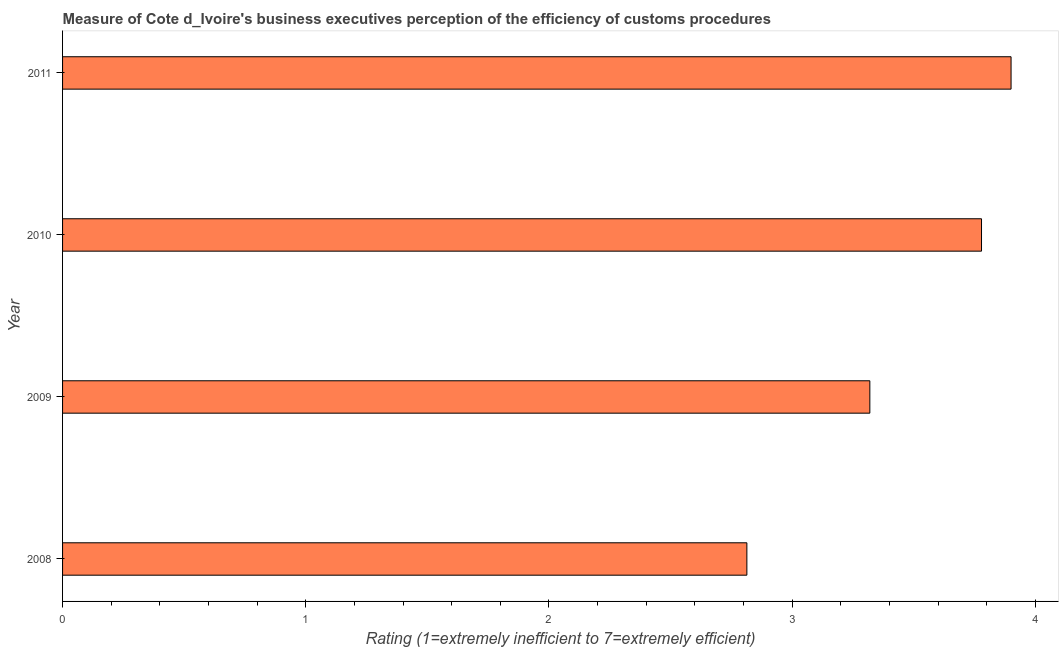What is the title of the graph?
Your answer should be very brief. Measure of Cote d_Ivoire's business executives perception of the efficiency of customs procedures. What is the label or title of the X-axis?
Make the answer very short. Rating (1=extremely inefficient to 7=extremely efficient). What is the rating measuring burden of customs procedure in 2008?
Keep it short and to the point. 2.81. Across all years, what is the minimum rating measuring burden of customs procedure?
Offer a very short reply. 2.81. What is the sum of the rating measuring burden of customs procedure?
Ensure brevity in your answer.  13.81. What is the difference between the rating measuring burden of customs procedure in 2008 and 2009?
Keep it short and to the point. -0.51. What is the average rating measuring burden of customs procedure per year?
Offer a terse response. 3.45. What is the median rating measuring burden of customs procedure?
Offer a terse response. 3.55. What is the ratio of the rating measuring burden of customs procedure in 2009 to that in 2011?
Your answer should be very brief. 0.85. Is the difference between the rating measuring burden of customs procedure in 2009 and 2011 greater than the difference between any two years?
Give a very brief answer. No. What is the difference between the highest and the second highest rating measuring burden of customs procedure?
Ensure brevity in your answer.  0.12. What is the difference between the highest and the lowest rating measuring burden of customs procedure?
Make the answer very short. 1.09. In how many years, is the rating measuring burden of customs procedure greater than the average rating measuring burden of customs procedure taken over all years?
Offer a terse response. 2. How many bars are there?
Your answer should be very brief. 4. Are all the bars in the graph horizontal?
Offer a very short reply. Yes. How many years are there in the graph?
Offer a terse response. 4. What is the difference between two consecutive major ticks on the X-axis?
Keep it short and to the point. 1. What is the Rating (1=extremely inefficient to 7=extremely efficient) of 2008?
Offer a terse response. 2.81. What is the Rating (1=extremely inefficient to 7=extremely efficient) in 2009?
Provide a succinct answer. 3.32. What is the Rating (1=extremely inefficient to 7=extremely efficient) in 2010?
Your answer should be very brief. 3.78. What is the Rating (1=extremely inefficient to 7=extremely efficient) of 2011?
Provide a succinct answer. 3.9. What is the difference between the Rating (1=extremely inefficient to 7=extremely efficient) in 2008 and 2009?
Make the answer very short. -0.51. What is the difference between the Rating (1=extremely inefficient to 7=extremely efficient) in 2008 and 2010?
Provide a short and direct response. -0.96. What is the difference between the Rating (1=extremely inefficient to 7=extremely efficient) in 2008 and 2011?
Offer a very short reply. -1.09. What is the difference between the Rating (1=extremely inefficient to 7=extremely efficient) in 2009 and 2010?
Provide a short and direct response. -0.46. What is the difference between the Rating (1=extremely inefficient to 7=extremely efficient) in 2009 and 2011?
Offer a terse response. -0.58. What is the difference between the Rating (1=extremely inefficient to 7=extremely efficient) in 2010 and 2011?
Provide a succinct answer. -0.12. What is the ratio of the Rating (1=extremely inefficient to 7=extremely efficient) in 2008 to that in 2009?
Provide a short and direct response. 0.85. What is the ratio of the Rating (1=extremely inefficient to 7=extremely efficient) in 2008 to that in 2010?
Provide a succinct answer. 0.74. What is the ratio of the Rating (1=extremely inefficient to 7=extremely efficient) in 2008 to that in 2011?
Provide a succinct answer. 0.72. What is the ratio of the Rating (1=extremely inefficient to 7=extremely efficient) in 2009 to that in 2010?
Ensure brevity in your answer.  0.88. What is the ratio of the Rating (1=extremely inefficient to 7=extremely efficient) in 2009 to that in 2011?
Offer a terse response. 0.85. 